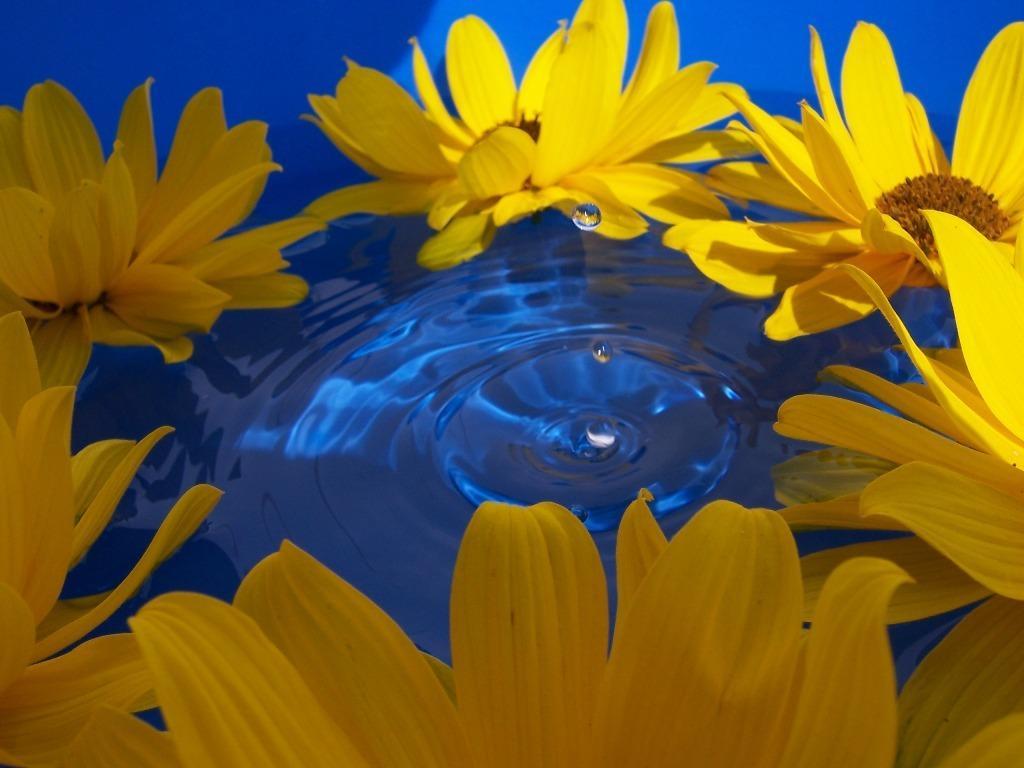In one or two sentences, can you explain what this image depicts? In this image, I can see many flowers on the water and in the middle I can water drops. 